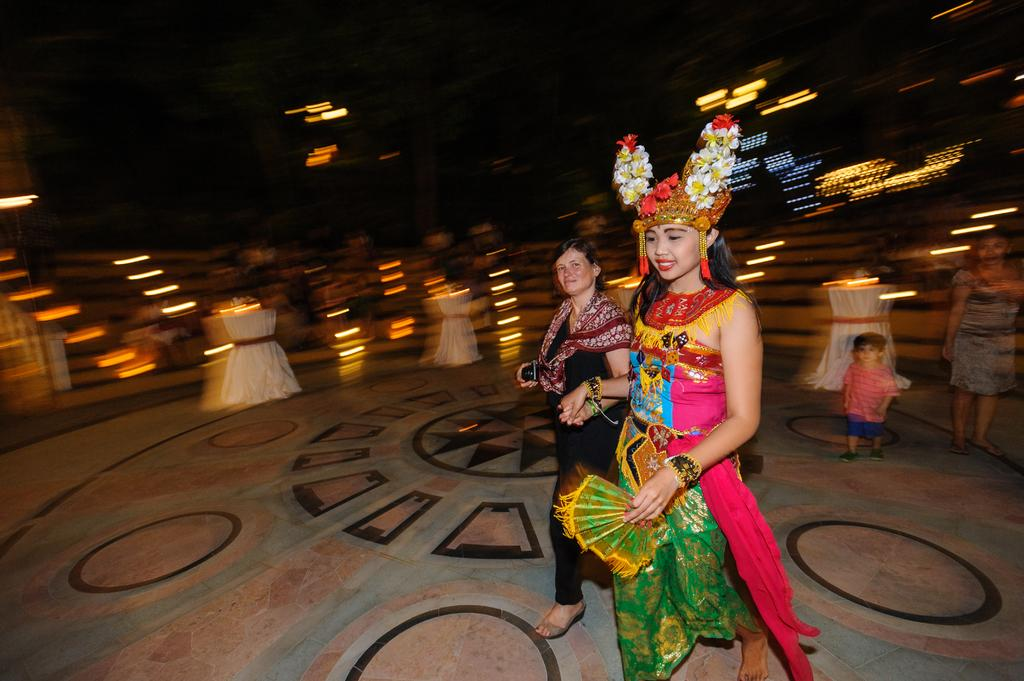What are the two persons in the image doing? The two persons in the image are walking. Can you describe the clothing of the person in front? The person in front is wearing a multi-color dress. What can be seen in the background of the image? There are lights visible in the background of the image. Is there a bridge visible in the image? No, there is no bridge present in the image. Where can the two persons rest in the image? The image does not show any specific location for the persons to rest. 